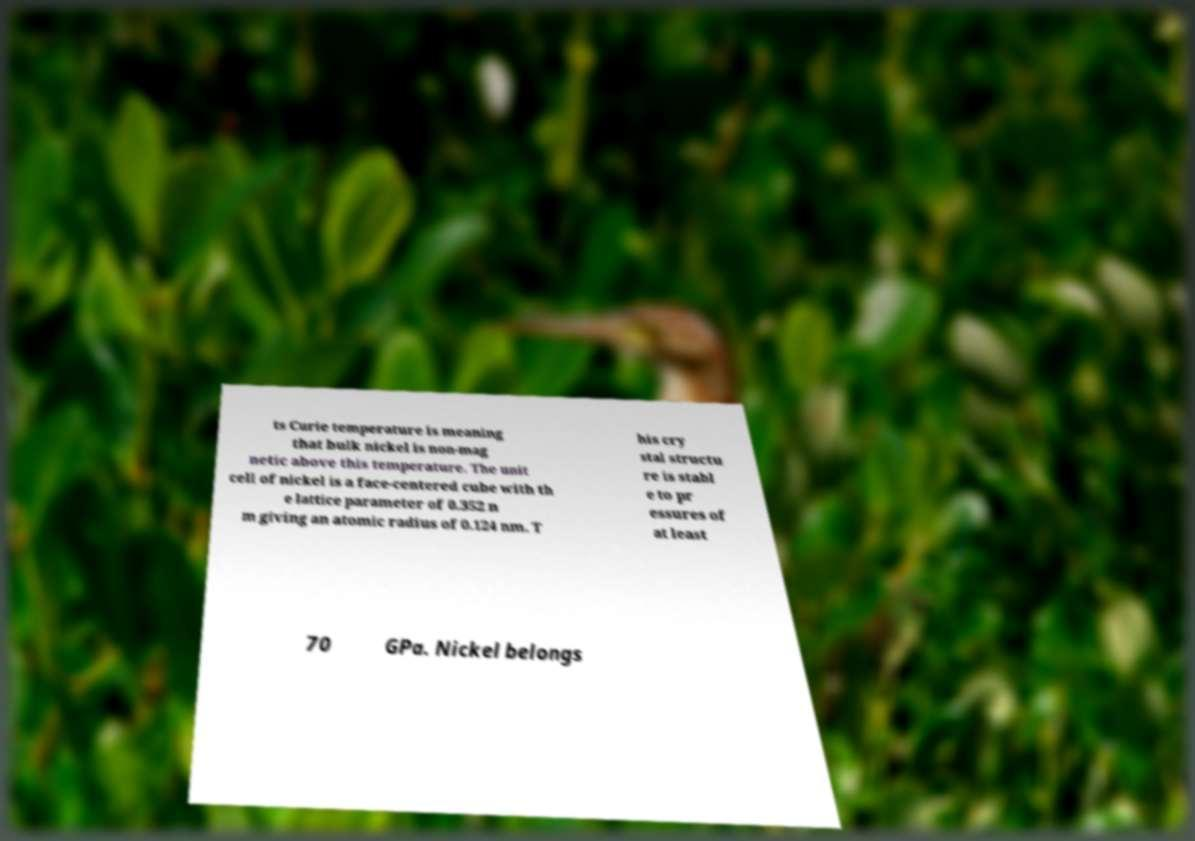What messages or text are displayed in this image? I need them in a readable, typed format. ts Curie temperature is meaning that bulk nickel is non-mag netic above this temperature. The unit cell of nickel is a face-centered cube with th e lattice parameter of 0.352 n m giving an atomic radius of 0.124 nm. T his cry stal structu re is stabl e to pr essures of at least 70 GPa. Nickel belongs 